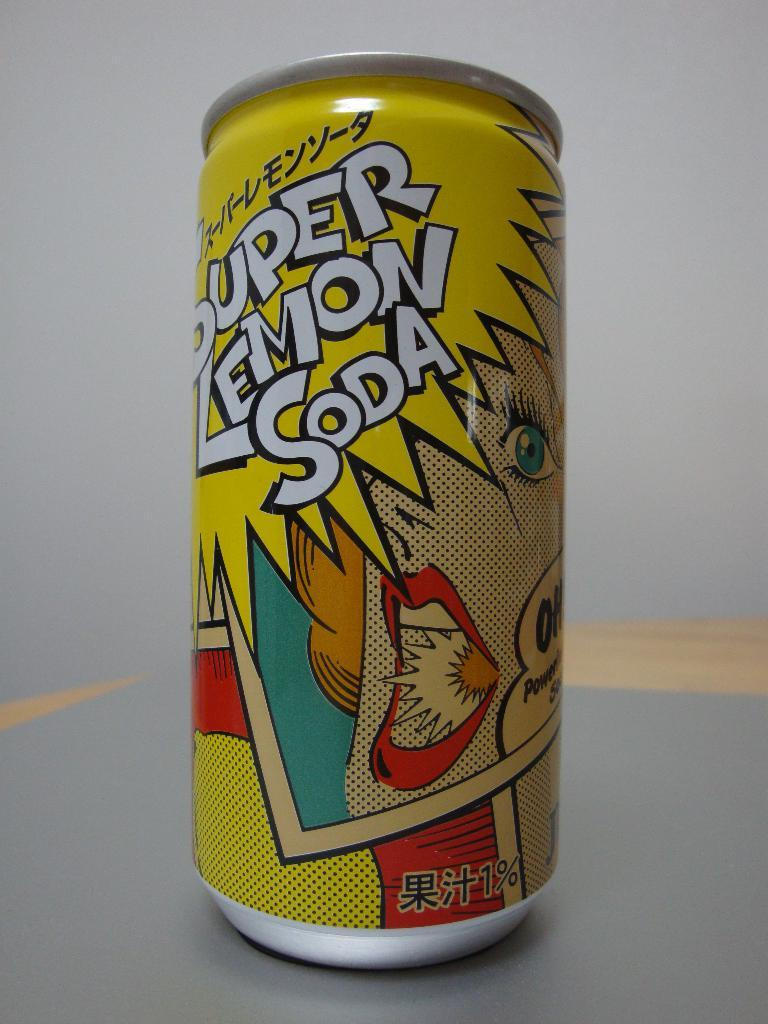<image>
Give a short and clear explanation of the subsequent image. The can contains no ordinary soda, it is a super lemon one. 